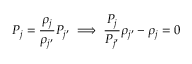<formula> <loc_0><loc_0><loc_500><loc_500>P _ { j } = \frac { \rho _ { j } } { \rho _ { j ^ { \prime } } } P _ { j ^ { \prime } } \implies \frac { P _ { j } } { P _ { j ^ { \prime } } } \rho _ { j ^ { \prime } } - \rho _ { j } = 0</formula> 